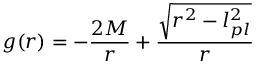<formula> <loc_0><loc_0><loc_500><loc_500>g ( r ) = - { \frac { 2 M } { r } } + { \frac { \sqrt { r ^ { 2 } - l _ { p l } ^ { 2 } } } { r } }</formula> 